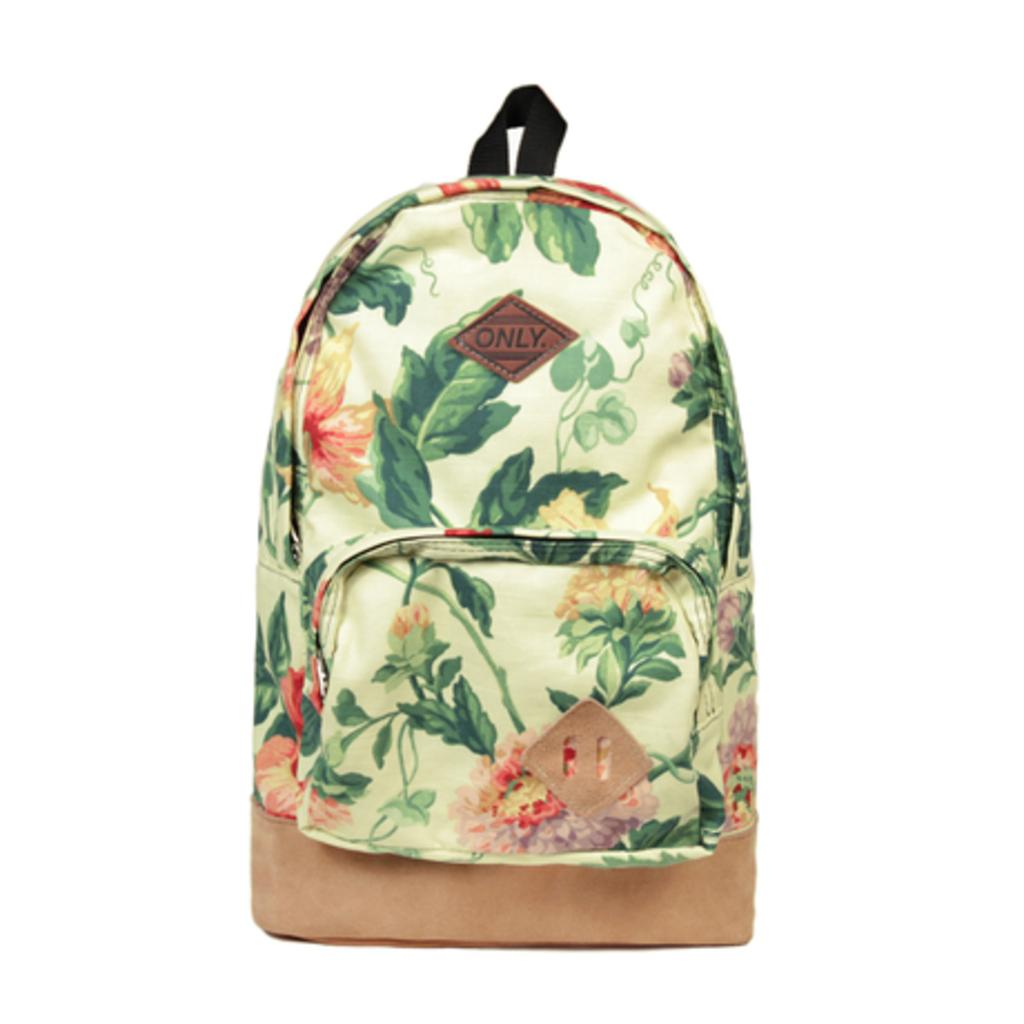What type of item is the main subject of the image? There is a beautiful bag in the image. Can you describe the design on the bag? The bag has a printed design on it. How many records are stacked on the wall next to the bag in the image? There are no records or walls present in the image; it only features a beautiful bag with a printed design. 